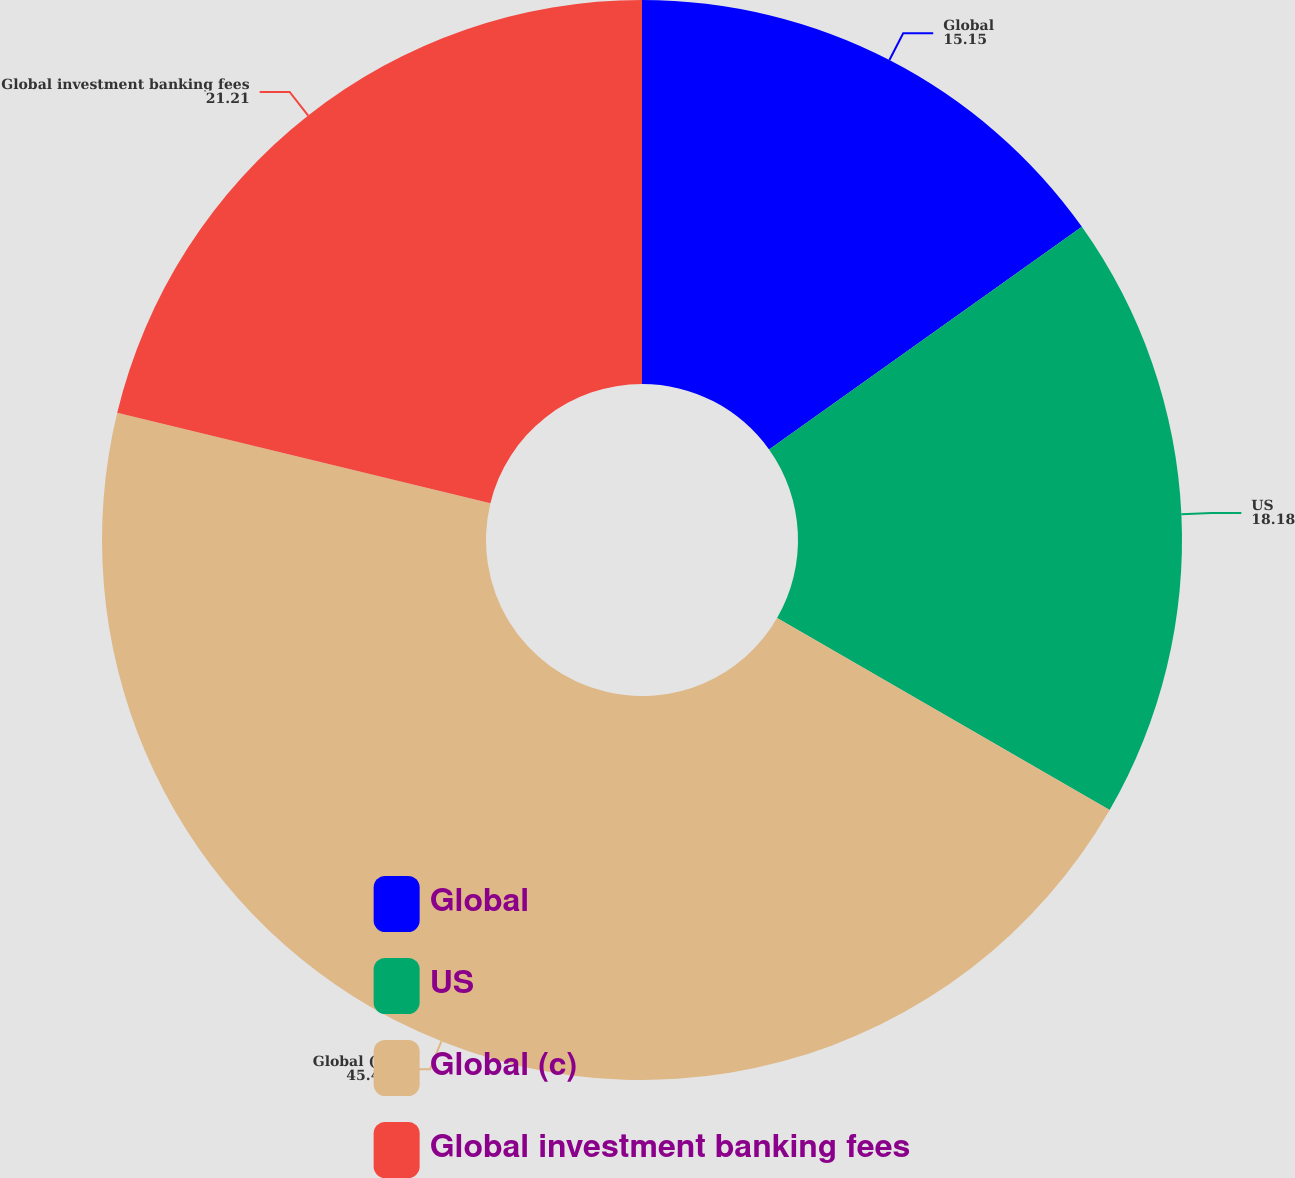Convert chart to OTSL. <chart><loc_0><loc_0><loc_500><loc_500><pie_chart><fcel>Global<fcel>US<fcel>Global (c)<fcel>Global investment banking fees<nl><fcel>15.15%<fcel>18.18%<fcel>45.45%<fcel>21.21%<nl></chart> 